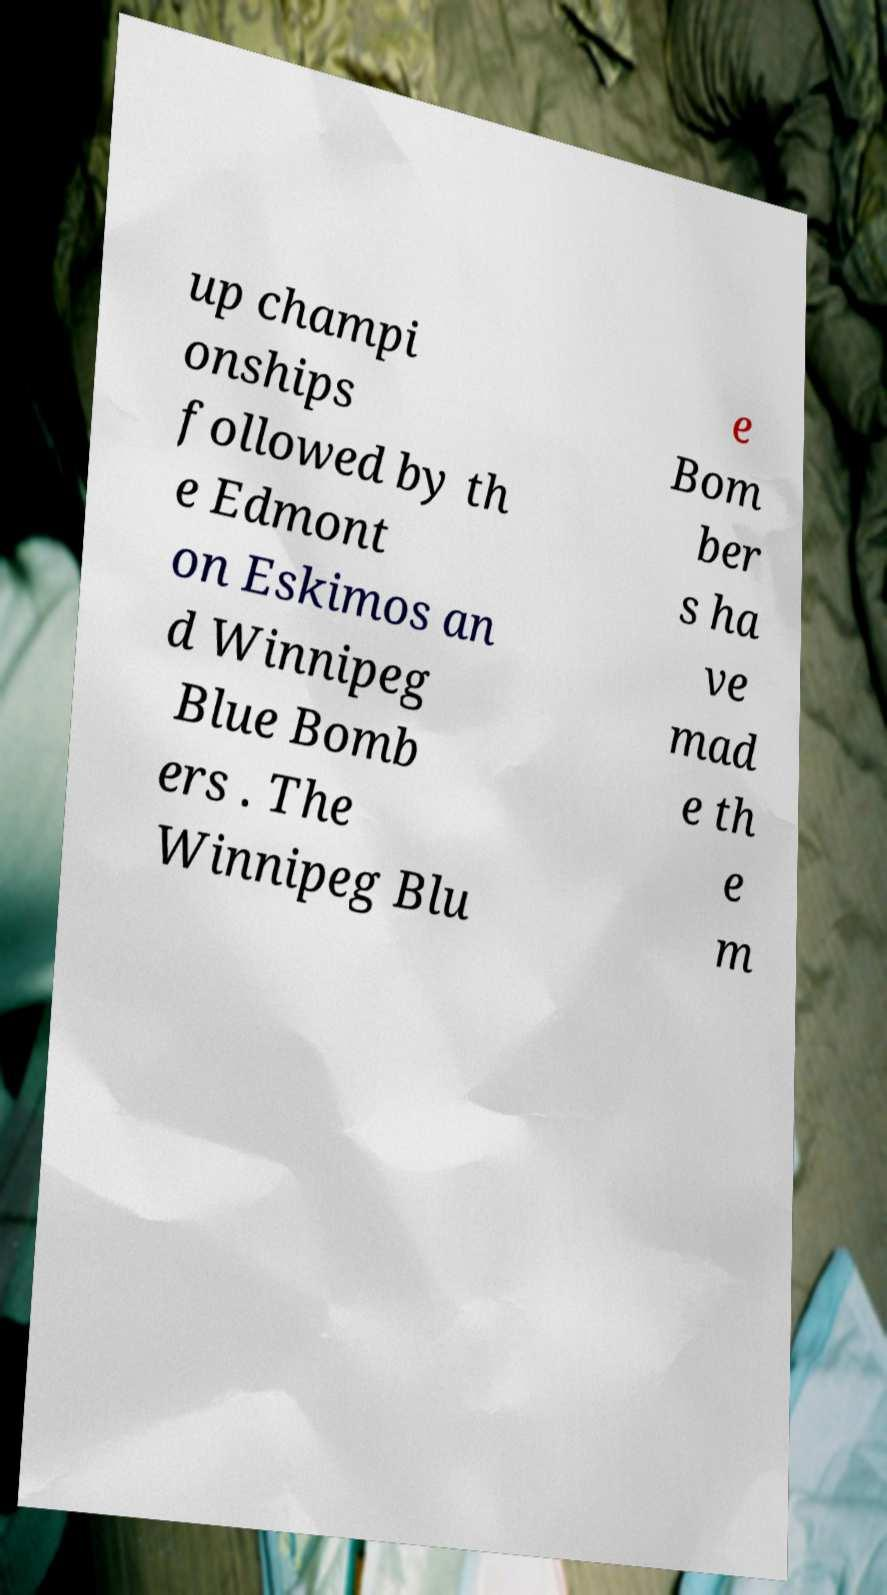There's text embedded in this image that I need extracted. Can you transcribe it verbatim? up champi onships followed by th e Edmont on Eskimos an d Winnipeg Blue Bomb ers . The Winnipeg Blu e Bom ber s ha ve mad e th e m 